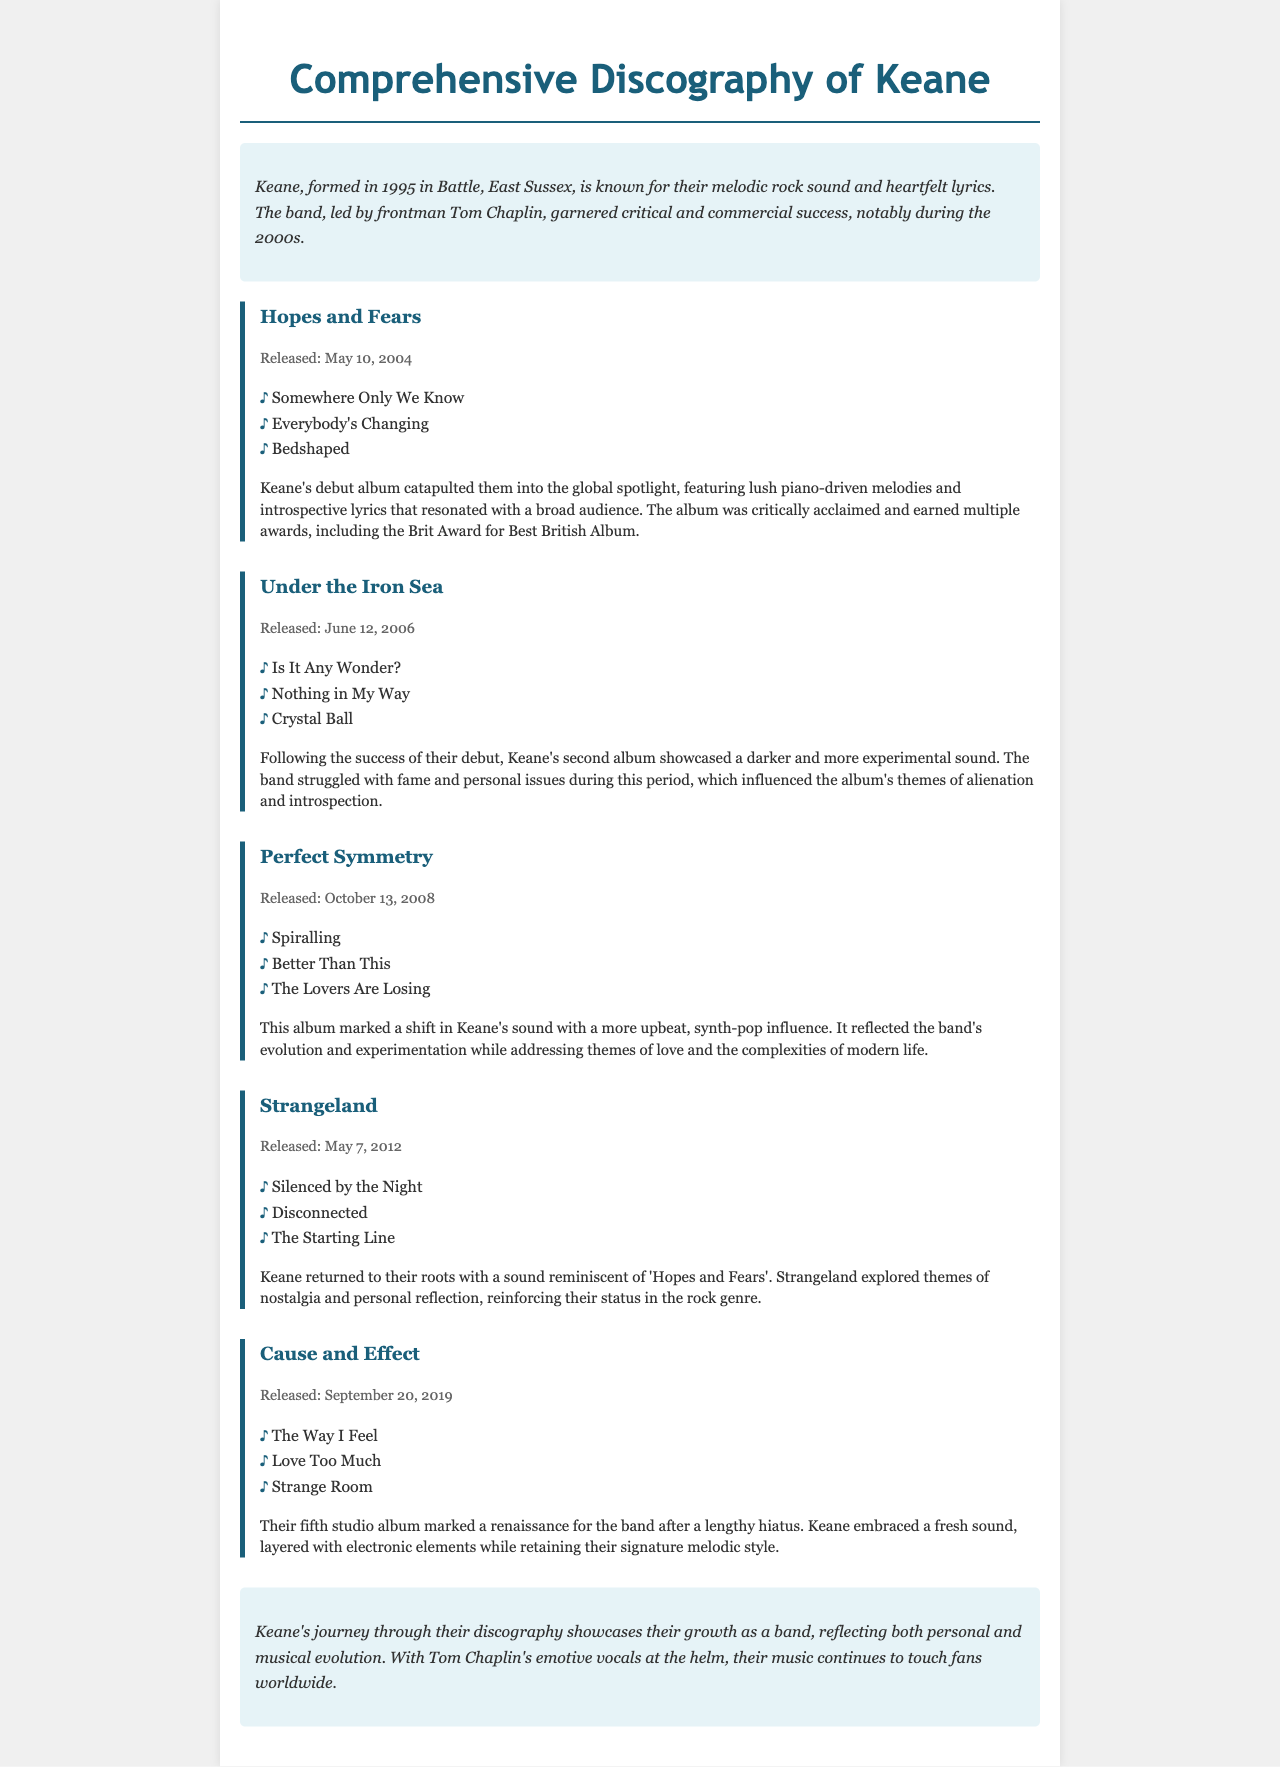What is the title of Keane's debut album? The title of Keane's debut album is mentioned at the beginning of the related section in the document.
Answer: Hopes and Fears When was "Under the Iron Sea" released? The release date of "Under the Iron Sea" is provided in the release info of the album in the document.
Answer: June 12, 2006 What key track is associated with the album "Perfect Symmetry"? The document lists several key tracks for "Perfect Symmetry," which can be easily identified in the respective section.
Answer: Spiralling How many albums are mentioned in the document? The document lists five separate albums in the discography section, which can be counted from the headings.
Answer: Five What significant shift in sound is noted for "Perfect Symmetry"? The historical context section of "Perfect Symmetry" reveals a notable change in the band’s musical approach, which is highlighted.
Answer: Upbeat, synth-pop influence What award did "Hopes and Fears" win? The document specifies that "Hopes and Fears" received a notable award in the historical context section related to the album.
Answer: Brit Award for Best British Album Which album marked a renaissance for the band? The historical context of the last album specifically mentions its importance in terms of renewal for Keane after a hiatus.
Answer: Cause and Effect What themes does the album "Strangeland" explore? The document highlights themes discussed in the historical context of "Strangeland," which reflects the band's journey.
Answer: Nostalgia and personal reflection 